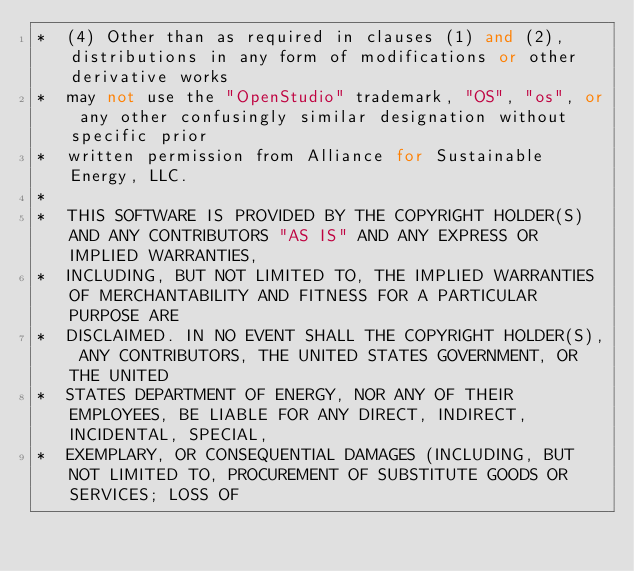<code> <loc_0><loc_0><loc_500><loc_500><_C++_>*  (4) Other than as required in clauses (1) and (2), distributions in any form of modifications or other derivative works
*  may not use the "OpenStudio" trademark, "OS", "os", or any other confusingly similar designation without specific prior
*  written permission from Alliance for Sustainable Energy, LLC.
*
*  THIS SOFTWARE IS PROVIDED BY THE COPYRIGHT HOLDER(S) AND ANY CONTRIBUTORS "AS IS" AND ANY EXPRESS OR IMPLIED WARRANTIES,
*  INCLUDING, BUT NOT LIMITED TO, THE IMPLIED WARRANTIES OF MERCHANTABILITY AND FITNESS FOR A PARTICULAR PURPOSE ARE
*  DISCLAIMED. IN NO EVENT SHALL THE COPYRIGHT HOLDER(S), ANY CONTRIBUTORS, THE UNITED STATES GOVERNMENT, OR THE UNITED
*  STATES DEPARTMENT OF ENERGY, NOR ANY OF THEIR EMPLOYEES, BE LIABLE FOR ANY DIRECT, INDIRECT, INCIDENTAL, SPECIAL,
*  EXEMPLARY, OR CONSEQUENTIAL DAMAGES (INCLUDING, BUT NOT LIMITED TO, PROCUREMENT OF SUBSTITUTE GOODS OR SERVICES; LOSS OF</code> 